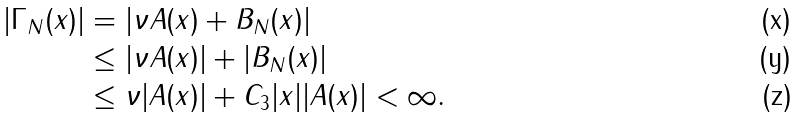<formula> <loc_0><loc_0><loc_500><loc_500>| \Gamma _ { N } ( x ) | & = | \nu A ( x ) + B _ { N } ( x ) | \\ & \leq | \nu A ( x ) | + | B _ { N } ( x ) | \\ & \leq \nu | A ( x ) | + C _ { 3 } | x | | A ( x ) | < \infty .</formula> 